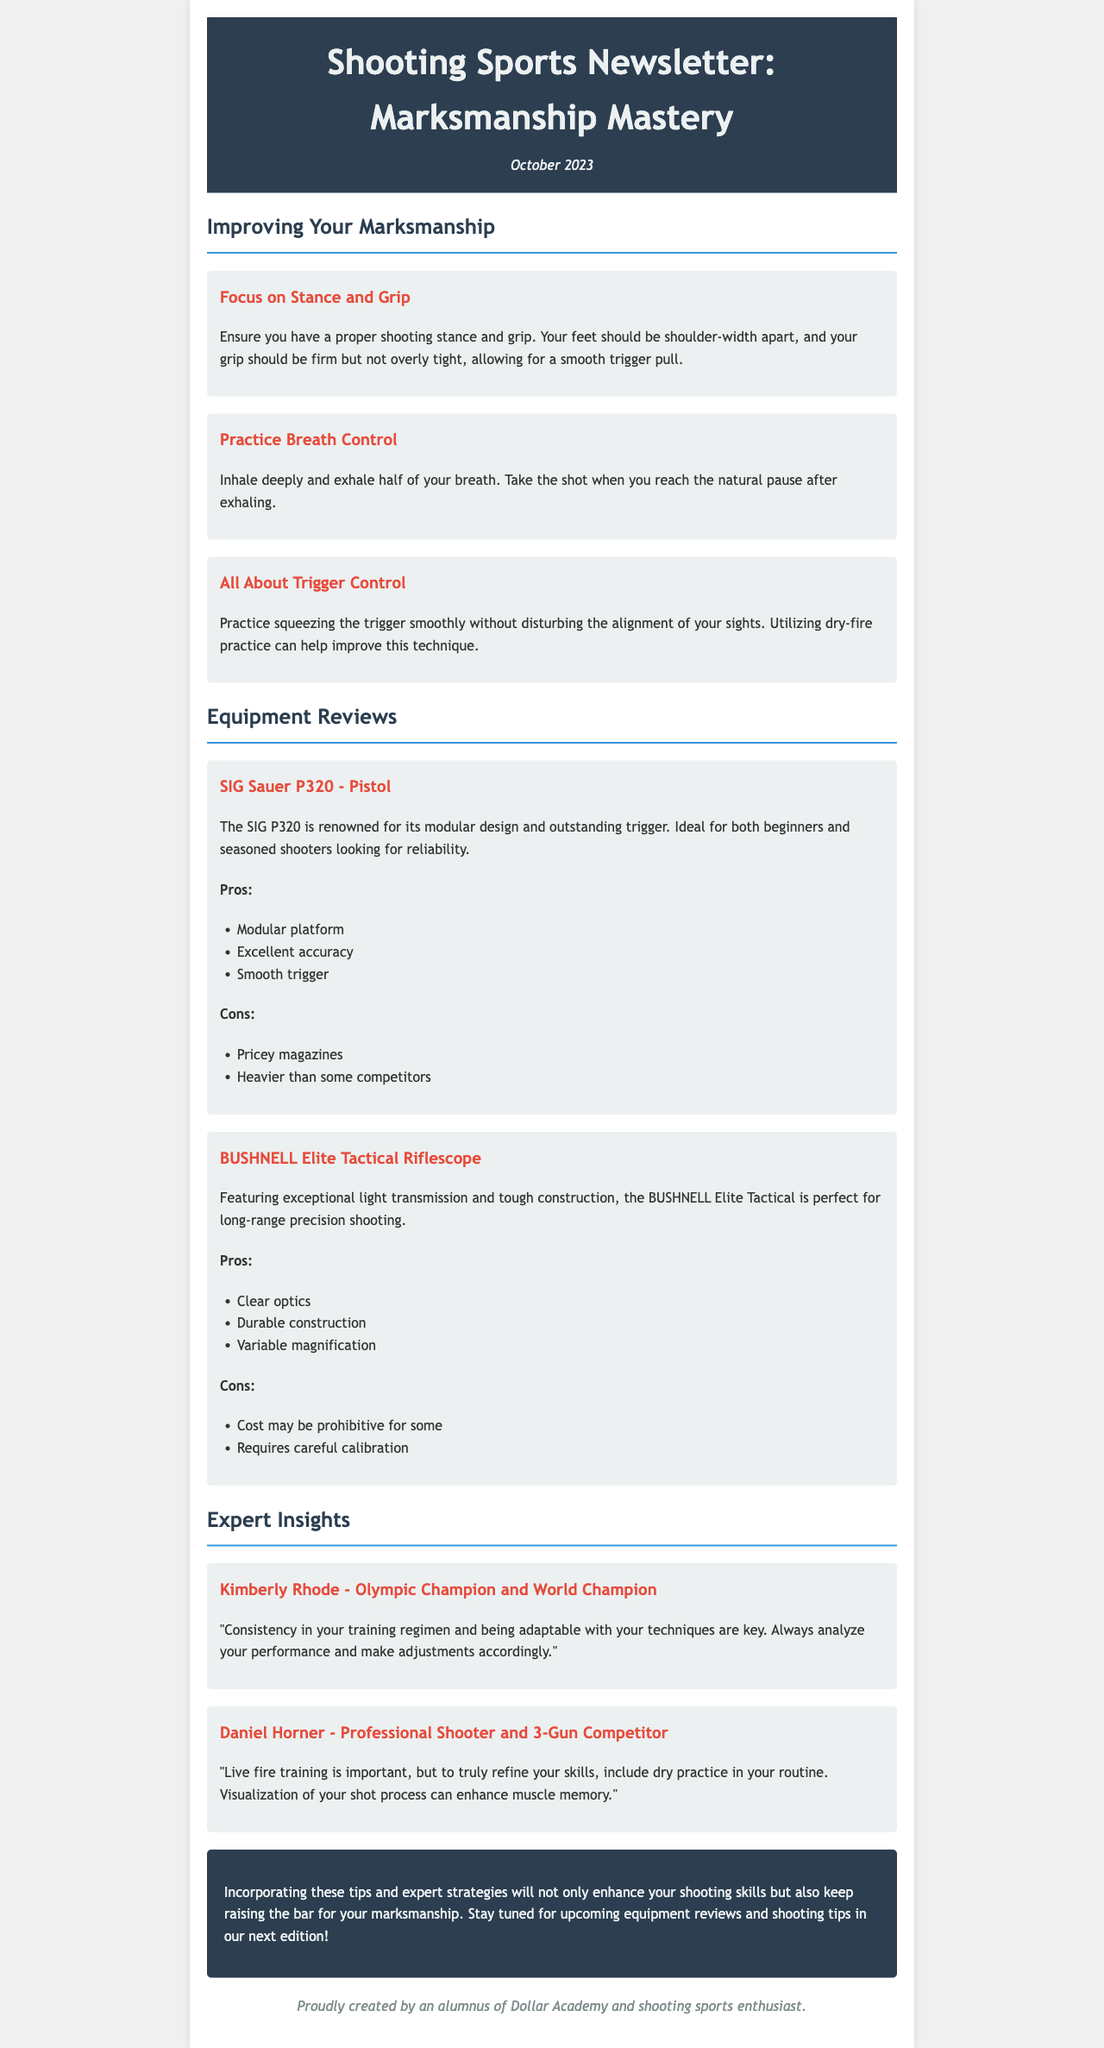what is the title of the newsletter? The title of the newsletter is mentioned at the beginning of the document.
Answer: Shooting Sports Newsletter: Marksmanship Mastery when was the newsletter published? The publication date is provided in the document in the header section.
Answer: October 2023 who is quoted as an Olympic Champion in the newsletter? This information is located in the Expert Insights section where quotes from experts are listed.
Answer: Kimberly Rhode what is a pro of the SIG Sauer P320? The pros and cons of the product are outlined in the Equipment Reviews section.
Answer: Modular platform what technique does Kimberly Rhode emphasize for improvement? The insights provided by experts often include specific techniques or advice.
Answer: Consistency in training name one of the cons of the BUSHNELL Elite Tactical Riflescope. The disadvantages of the equipment are specified in the review section.
Answer: Cost may be prohibitive for some how many tips are listed under Improving Your Marksmanship? The number of tips can be counted from the section providing improving marksmanship advice.
Answer: Three what does Daniel Horner suggest including in your training routine? The advice given in the quotes often contains suggestions for training.
Answer: Dry practice which product is described as ideal for long-range precision shooting? The product reviews provide specific recommendations for types of shooting.
Answer: BUSHNELL Elite Tactical Riflescope 